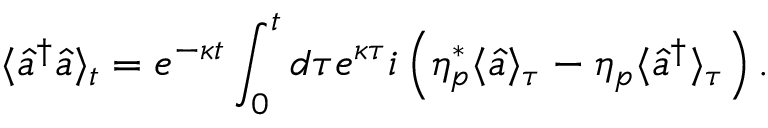<formula> <loc_0><loc_0><loc_500><loc_500>\langle \hat { a } ^ { \dagger } \hat { a } \rangle _ { t } = e ^ { - \kappa t } \int _ { 0 } ^ { t } d \tau e ^ { \kappa \tau } i \left ( \eta _ { p } ^ { * } \langle \hat { a } \rangle _ { \tau } - \eta _ { p } \langle \hat { a } ^ { \dagger } \rangle _ { \tau } \right ) .</formula> 